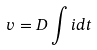Convert formula to latex. <formula><loc_0><loc_0><loc_500><loc_500>v = D \int i d t</formula> 